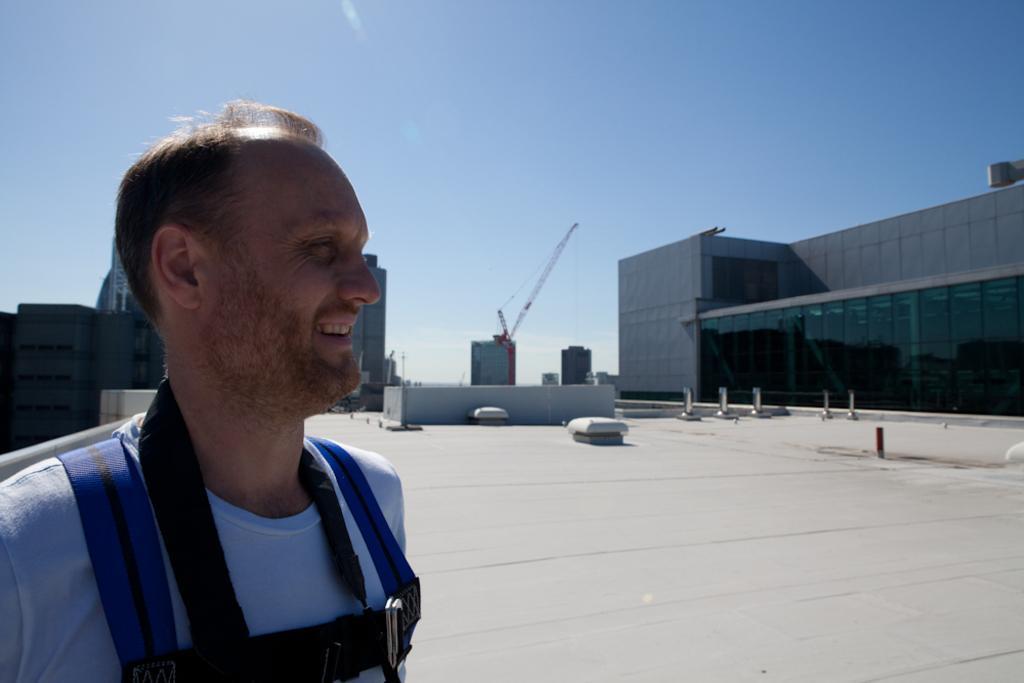Can you describe this image briefly? In this image I can see a person standing on the terrace of a building. I can see other buildings on the right hand side. I can see a crane on a building. I can see other buildings behind the person standing. I can see the sky at the top of the image. 